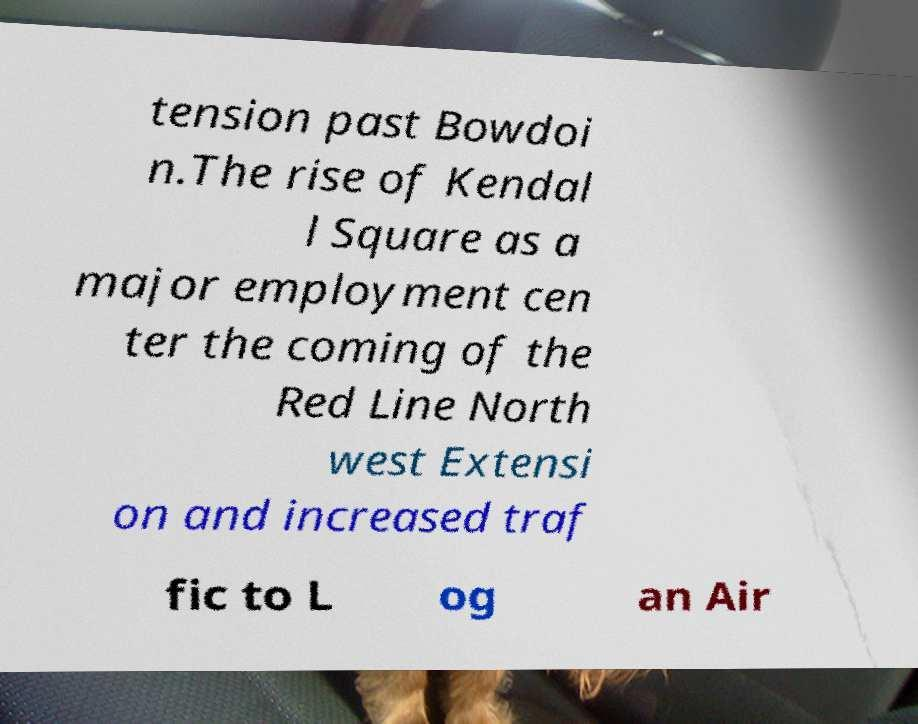There's text embedded in this image that I need extracted. Can you transcribe it verbatim? tension past Bowdoi n.The rise of Kendal l Square as a major employment cen ter the coming of the Red Line North west Extensi on and increased traf fic to L og an Air 